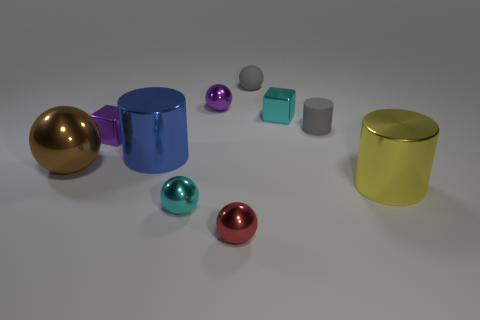There is a small matte thing that is the same color as the tiny cylinder; what shape is it?
Provide a short and direct response. Sphere. What number of small matte things are the same color as the rubber ball?
Offer a terse response. 1. Is the color of the small cylinder the same as the tiny matte sphere?
Ensure brevity in your answer.  Yes. What is the size of the purple metallic cube?
Your answer should be compact. Small. There is a brown sphere that is the same size as the yellow object; what material is it?
Your response must be concise. Metal. What number of blue metal cylinders are on the left side of the blue thing?
Your answer should be very brief. 0. Are the big brown sphere behind the large yellow cylinder and the cyan thing that is behind the small purple metal block made of the same material?
Provide a succinct answer. Yes. What shape is the small purple shiny thing that is behind the tiny metal block on the left side of the purple thing behind the matte cylinder?
Make the answer very short. Sphere. What is the shape of the large brown metallic object?
Provide a succinct answer. Sphere. What shape is the yellow object that is the same size as the blue metal cylinder?
Give a very brief answer. Cylinder. 